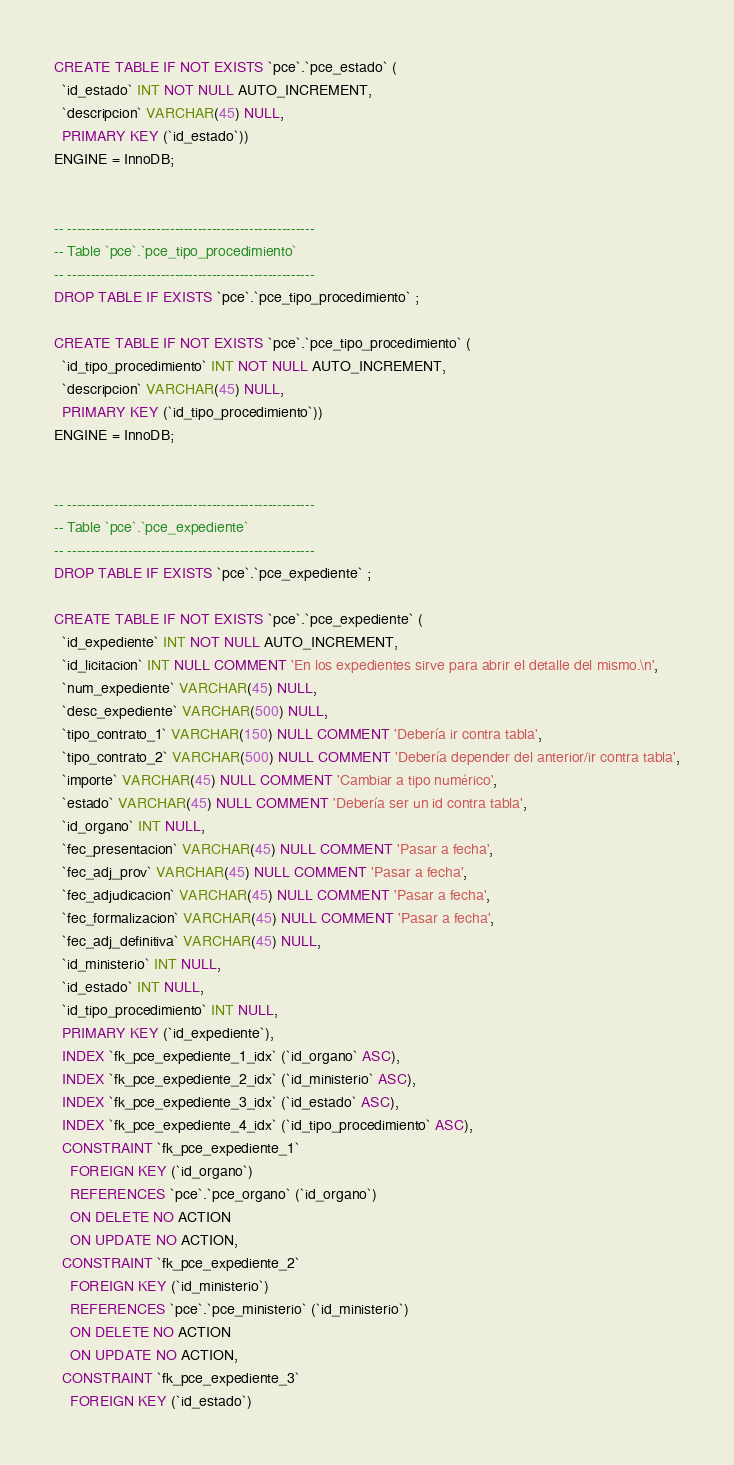<code> <loc_0><loc_0><loc_500><loc_500><_SQL_>
CREATE TABLE IF NOT EXISTS `pce`.`pce_estado` (
  `id_estado` INT NOT NULL AUTO_INCREMENT,
  `descripcion` VARCHAR(45) NULL,
  PRIMARY KEY (`id_estado`))
ENGINE = InnoDB;


-- -----------------------------------------------------
-- Table `pce`.`pce_tipo_procedimiento`
-- -----------------------------------------------------
DROP TABLE IF EXISTS `pce`.`pce_tipo_procedimiento` ;

CREATE TABLE IF NOT EXISTS `pce`.`pce_tipo_procedimiento` (
  `id_tipo_procedimiento` INT NOT NULL AUTO_INCREMENT,
  `descripcion` VARCHAR(45) NULL,
  PRIMARY KEY (`id_tipo_procedimiento`))
ENGINE = InnoDB;


-- -----------------------------------------------------
-- Table `pce`.`pce_expediente`
-- -----------------------------------------------------
DROP TABLE IF EXISTS `pce`.`pce_expediente` ;

CREATE TABLE IF NOT EXISTS `pce`.`pce_expediente` (
  `id_expediente` INT NOT NULL AUTO_INCREMENT,
  `id_licitacion` INT NULL COMMENT 'En los expedientes sirve para abrir el detalle del mismo.\n',
  `num_expediente` VARCHAR(45) NULL,
  `desc_expediente` VARCHAR(500) NULL,
  `tipo_contrato_1` VARCHAR(150) NULL COMMENT 'Debería ir contra tabla',
  `tipo_contrato_2` VARCHAR(500) NULL COMMENT 'Debería depender del anterior/ir contra tabla',
  `importe` VARCHAR(45) NULL COMMENT 'Cambiar a tipo numérico',
  `estado` VARCHAR(45) NULL COMMENT 'Debería ser un id contra tabla',
  `id_organo` INT NULL,
  `fec_presentacion` VARCHAR(45) NULL COMMENT 'Pasar a fecha',
  `fec_adj_prov` VARCHAR(45) NULL COMMENT 'Pasar a fecha',
  `fec_adjudicacion` VARCHAR(45) NULL COMMENT 'Pasar a fecha',
  `fec_formalizacion` VARCHAR(45) NULL COMMENT 'Pasar a fecha',
  `fec_adj_definitiva` VARCHAR(45) NULL,
  `id_ministerio` INT NULL,
  `id_estado` INT NULL,
  `id_tipo_procedimiento` INT NULL,
  PRIMARY KEY (`id_expediente`),
  INDEX `fk_pce_expediente_1_idx` (`id_organo` ASC),
  INDEX `fk_pce_expediente_2_idx` (`id_ministerio` ASC),
  INDEX `fk_pce_expediente_3_idx` (`id_estado` ASC),
  INDEX `fk_pce_expediente_4_idx` (`id_tipo_procedimiento` ASC),
  CONSTRAINT `fk_pce_expediente_1`
    FOREIGN KEY (`id_organo`)
    REFERENCES `pce`.`pce_organo` (`id_organo`)
    ON DELETE NO ACTION
    ON UPDATE NO ACTION,
  CONSTRAINT `fk_pce_expediente_2`
    FOREIGN KEY (`id_ministerio`)
    REFERENCES `pce`.`pce_ministerio` (`id_ministerio`)
    ON DELETE NO ACTION
    ON UPDATE NO ACTION,
  CONSTRAINT `fk_pce_expediente_3`
    FOREIGN KEY (`id_estado`)</code> 